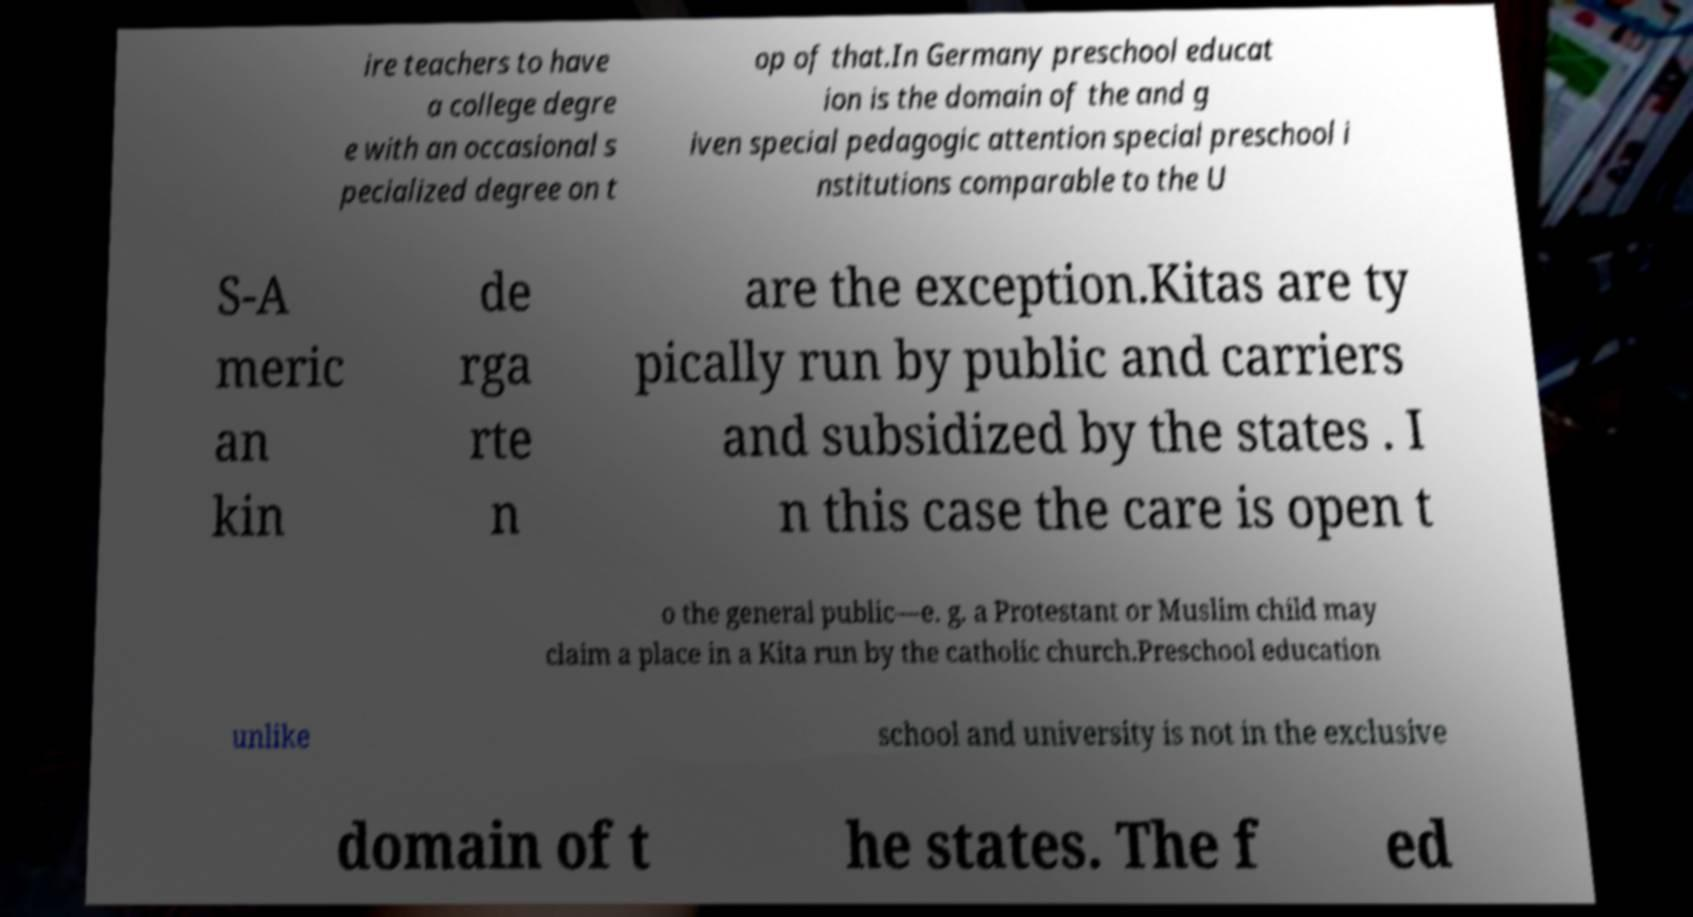What messages or text are displayed in this image? I need them in a readable, typed format. ire teachers to have a college degre e with an occasional s pecialized degree on t op of that.In Germany preschool educat ion is the domain of the and g iven special pedagogic attention special preschool i nstitutions comparable to the U S-A meric an kin de rga rte n are the exception.Kitas are ty pically run by public and carriers and subsidized by the states . I n this case the care is open t o the general public—e. g. a Protestant or Muslim child may claim a place in a Kita run by the catholic church.Preschool education unlike school and university is not in the exclusive domain of t he states. The f ed 